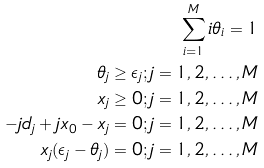<formula> <loc_0><loc_0><loc_500><loc_500>\sum _ { i = 1 } ^ { M } i \theta _ { i } = 1 \\ \theta _ { j } \geq \epsilon _ { j } ; j = 1 , 2 , \dots , M \\ x _ { j } \geq 0 ; j = 1 , 2 , \dots , M \\ - j d _ { j } + j x _ { 0 } - x _ { j } = 0 ; j = 1 , 2 , \dots , M \\ x _ { j } ( \epsilon _ { j } - \theta _ { j } ) = 0 ; j = 1 , 2 , \dots , M</formula> 